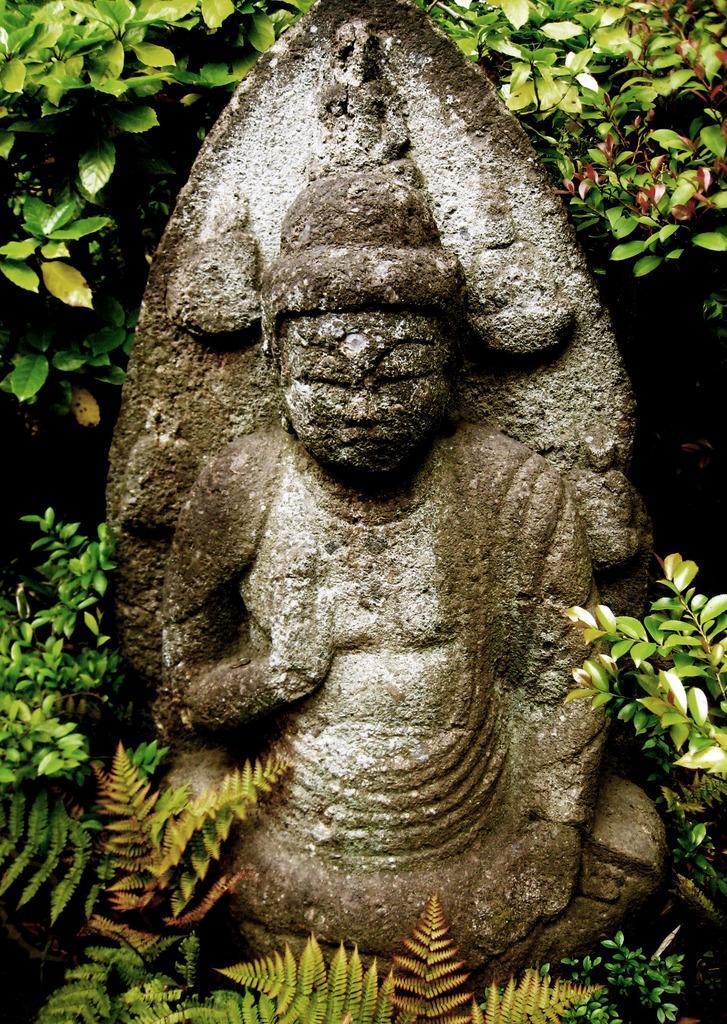Can you describe this image briefly? In the center of the image, we can see a statue and in the background, there are plants. 